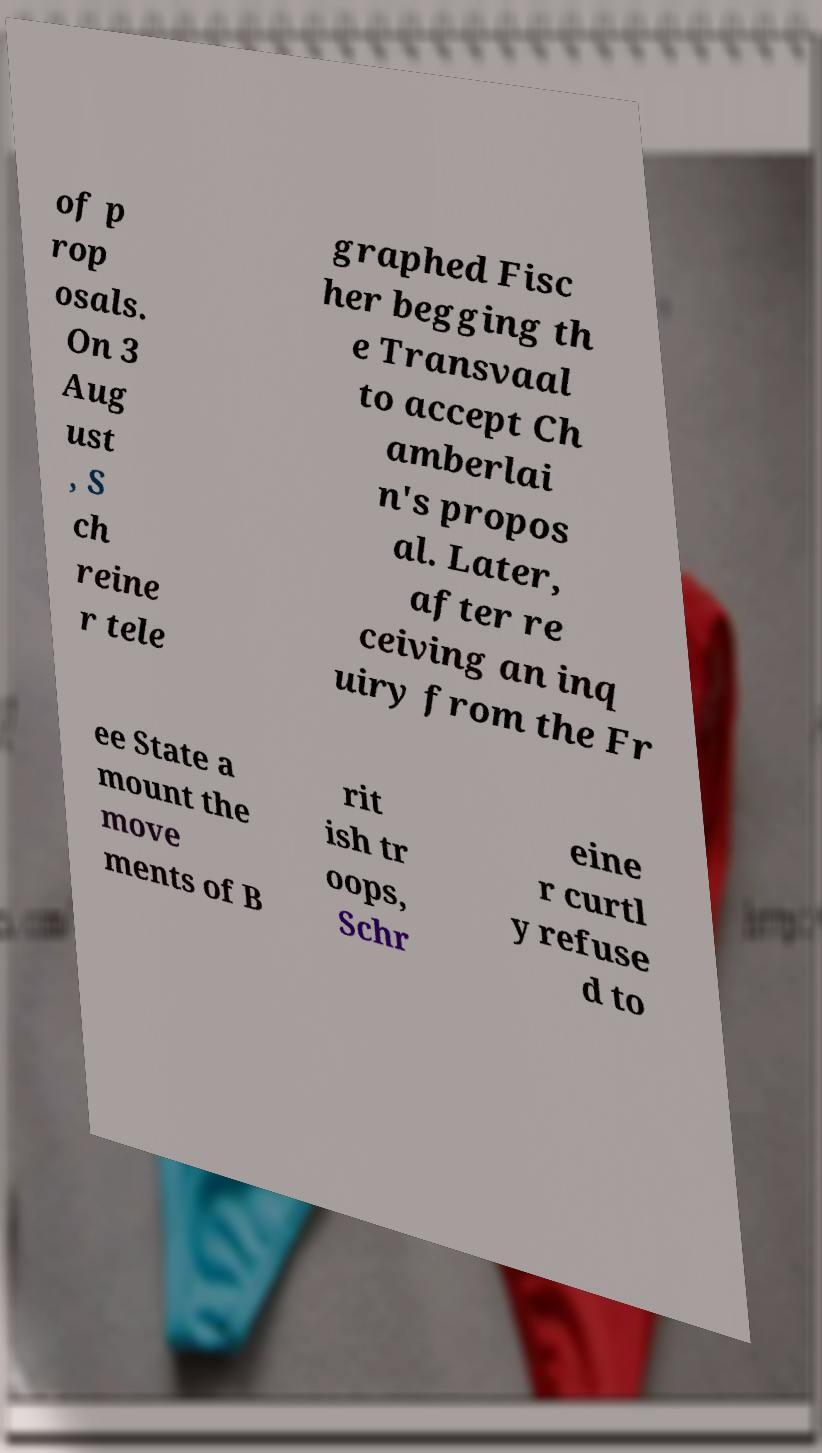Could you assist in decoding the text presented in this image and type it out clearly? of p rop osals. On 3 Aug ust , S ch reine r tele graphed Fisc her begging th e Transvaal to accept Ch amberlai n's propos al. Later, after re ceiving an inq uiry from the Fr ee State a mount the move ments of B rit ish tr oops, Schr eine r curtl y refuse d to 